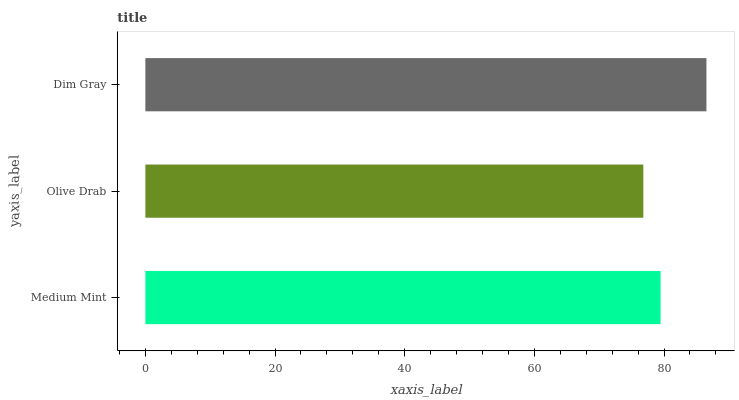Is Olive Drab the minimum?
Answer yes or no. Yes. Is Dim Gray the maximum?
Answer yes or no. Yes. Is Dim Gray the minimum?
Answer yes or no. No. Is Olive Drab the maximum?
Answer yes or no. No. Is Dim Gray greater than Olive Drab?
Answer yes or no. Yes. Is Olive Drab less than Dim Gray?
Answer yes or no. Yes. Is Olive Drab greater than Dim Gray?
Answer yes or no. No. Is Dim Gray less than Olive Drab?
Answer yes or no. No. Is Medium Mint the high median?
Answer yes or no. Yes. Is Medium Mint the low median?
Answer yes or no. Yes. Is Dim Gray the high median?
Answer yes or no. No. Is Dim Gray the low median?
Answer yes or no. No. 